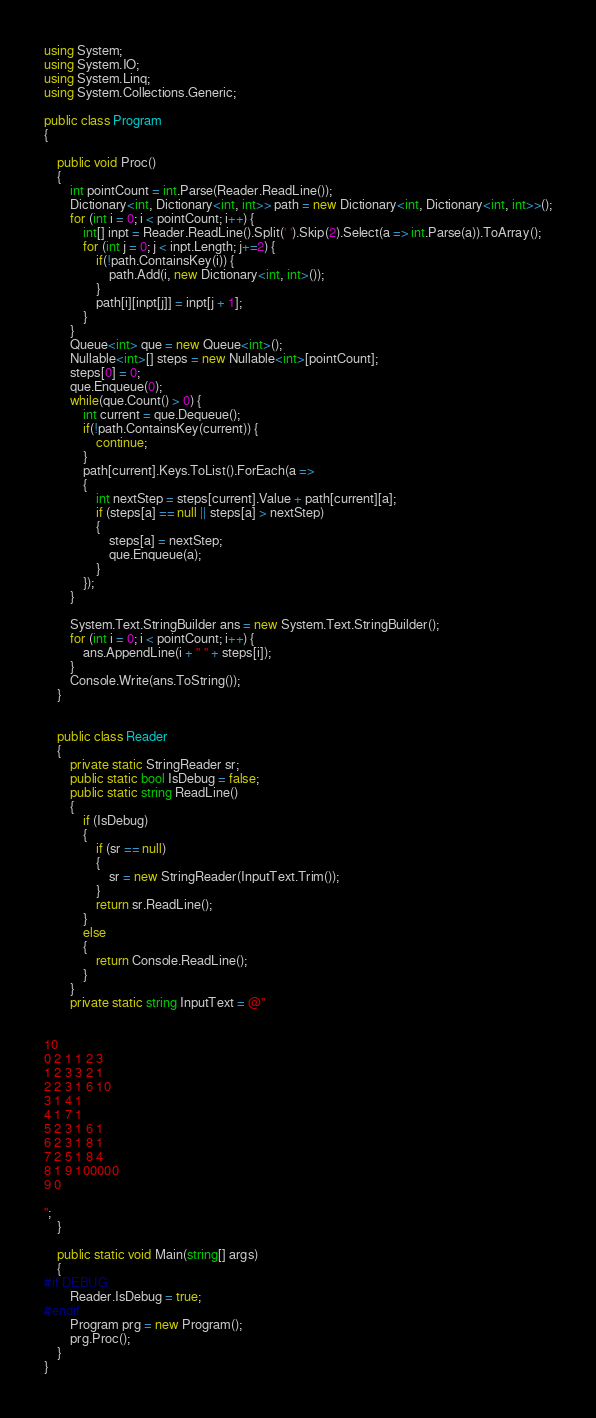Convert code to text. <code><loc_0><loc_0><loc_500><loc_500><_C#_>using System;
using System.IO;
using System.Linq;
using System.Collections.Generic;

public class Program
{

	public void Proc()
	{
        int pointCount = int.Parse(Reader.ReadLine());
        Dictionary<int, Dictionary<int, int>> path = new Dictionary<int, Dictionary<int, int>>();
        for (int i = 0; i < pointCount; i++) {
            int[] inpt = Reader.ReadLine().Split(' ').Skip(2).Select(a => int.Parse(a)).ToArray();
            for (int j = 0; j < inpt.Length; j+=2) {
                if(!path.ContainsKey(i)) {
                    path.Add(i, new Dictionary<int, int>());
                }
                path[i][inpt[j]] = inpt[j + 1];
            }
        }
        Queue<int> que = new Queue<int>();
        Nullable<int>[] steps = new Nullable<int>[pointCount];
        steps[0] = 0;
        que.Enqueue(0);
        while(que.Count() > 0) {
            int current = que.Dequeue();
            if(!path.ContainsKey(current)) {
                continue;
            }
            path[current].Keys.ToList().ForEach(a =>
            {
                int nextStep = steps[current].Value + path[current][a];
                if (steps[a] == null || steps[a] > nextStep)
                {
                    steps[a] = nextStep;
                    que.Enqueue(a);
                }
            });
        }

        System.Text.StringBuilder ans = new System.Text.StringBuilder();
        for (int i = 0; i < pointCount; i++) {
            ans.AppendLine(i + " " + steps[i]);
        }
        Console.Write(ans.ToString());
    }


	public class Reader
	{
		private static StringReader sr;
		public static bool IsDebug = false;
		public static string ReadLine()
		{
			if (IsDebug)
			{
				if (sr == null)
				{
					sr = new StringReader(InputText.Trim());
				}
				return sr.ReadLine();
			}
			else
			{
				return Console.ReadLine();
			}
		}
		private static string InputText = @"


10
0 2 1 1 2 3
1 2 3 3 2 1
2 2 3 1 6 10
3 1 4 1
4 1 7 1
5 2 3 1 6 1
6 2 3 1 8 1
7 2 5 1 8 4
8 1 9 100000
9 0

";
	}

	public static void Main(string[] args)
	{
#if DEBUG
		Reader.IsDebug = true;
#endif
		Program prg = new Program();
		prg.Proc();
	}
}</code> 